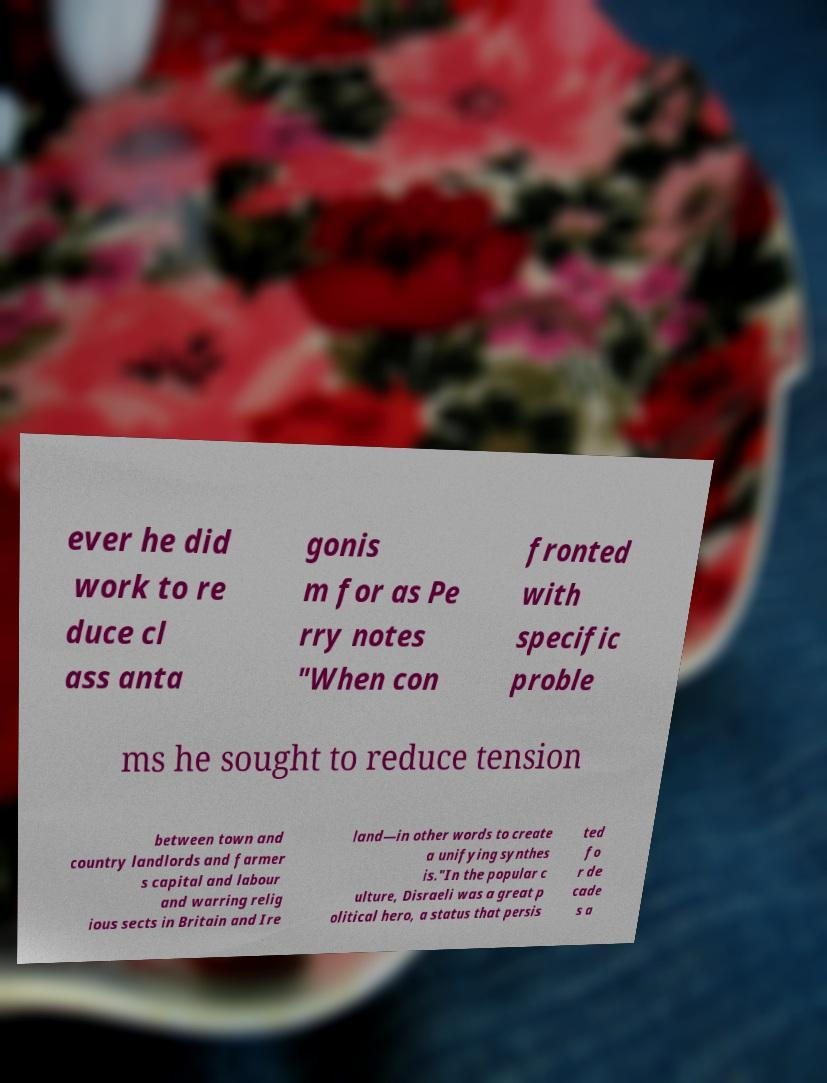I need the written content from this picture converted into text. Can you do that? ever he did work to re duce cl ass anta gonis m for as Pe rry notes "When con fronted with specific proble ms he sought to reduce tension between town and country landlords and farmer s capital and labour and warring relig ious sects in Britain and Ire land—in other words to create a unifying synthes is."In the popular c ulture, Disraeli was a great p olitical hero, a status that persis ted fo r de cade s a 